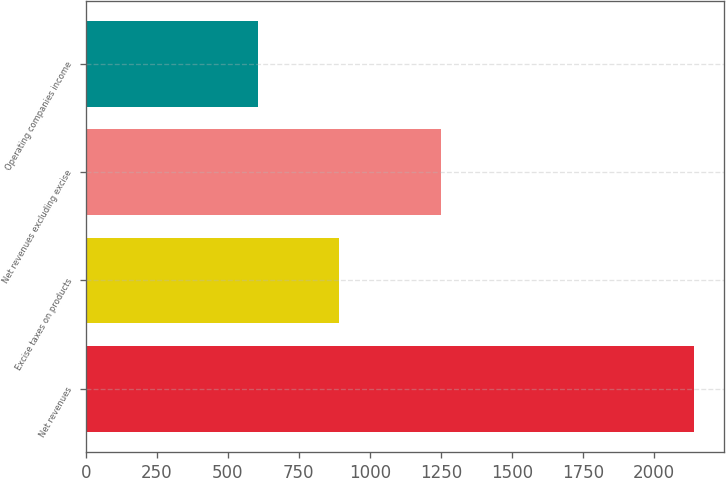Convert chart to OTSL. <chart><loc_0><loc_0><loc_500><loc_500><bar_chart><fcel>Net revenues<fcel>Excise taxes on products<fcel>Net revenues excluding excise<fcel>Operating companies income<nl><fcel>2141<fcel>891<fcel>1250<fcel>608<nl></chart> 